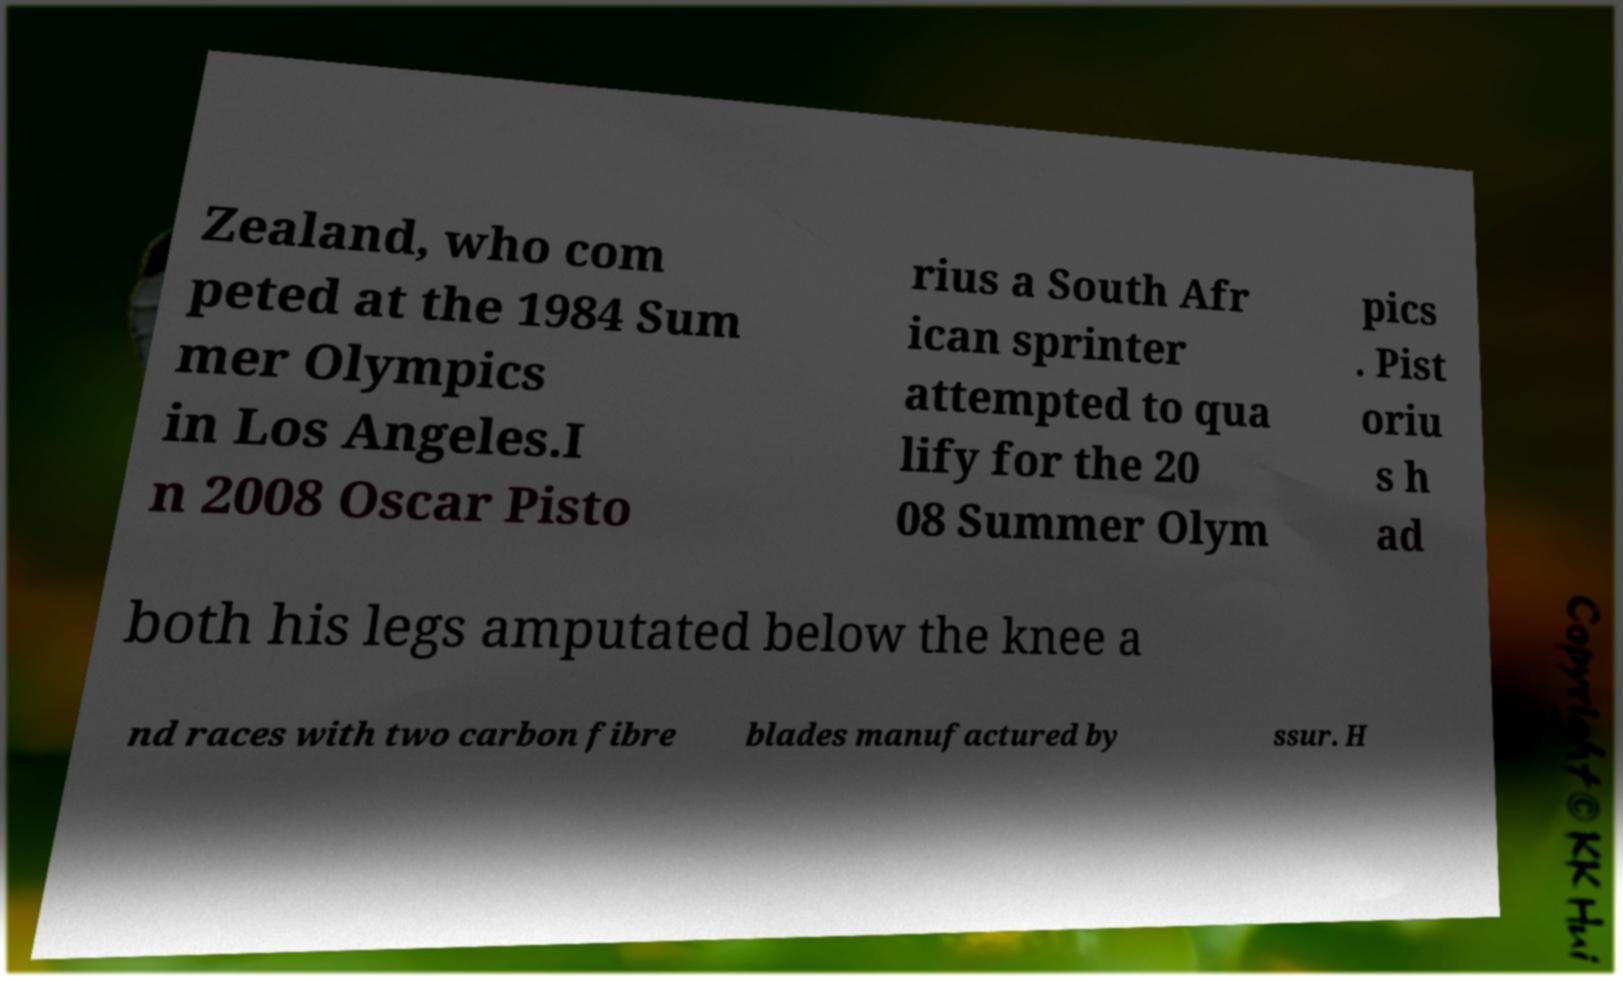Can you read and provide the text displayed in the image?This photo seems to have some interesting text. Can you extract and type it out for me? Zealand, who com peted at the 1984 Sum mer Olympics in Los Angeles.I n 2008 Oscar Pisto rius a South Afr ican sprinter attempted to qua lify for the 20 08 Summer Olym pics . Pist oriu s h ad both his legs amputated below the knee a nd races with two carbon fibre blades manufactured by ssur. H 